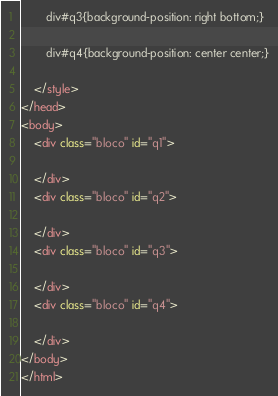<code> <loc_0><loc_0><loc_500><loc_500><_HTML_>
        div#q3{background-position: right bottom;}

        div#q4{background-position: center center;}

    </style>
</head>
<body>
    <div class="bloco" id="q1">

    </div>
    <div class="bloco" id="q2">

    </div>
    <div class="bloco" id="q3">

    </div>
    <div class="bloco" id="q4">

    </div>
</body>
</html></code> 